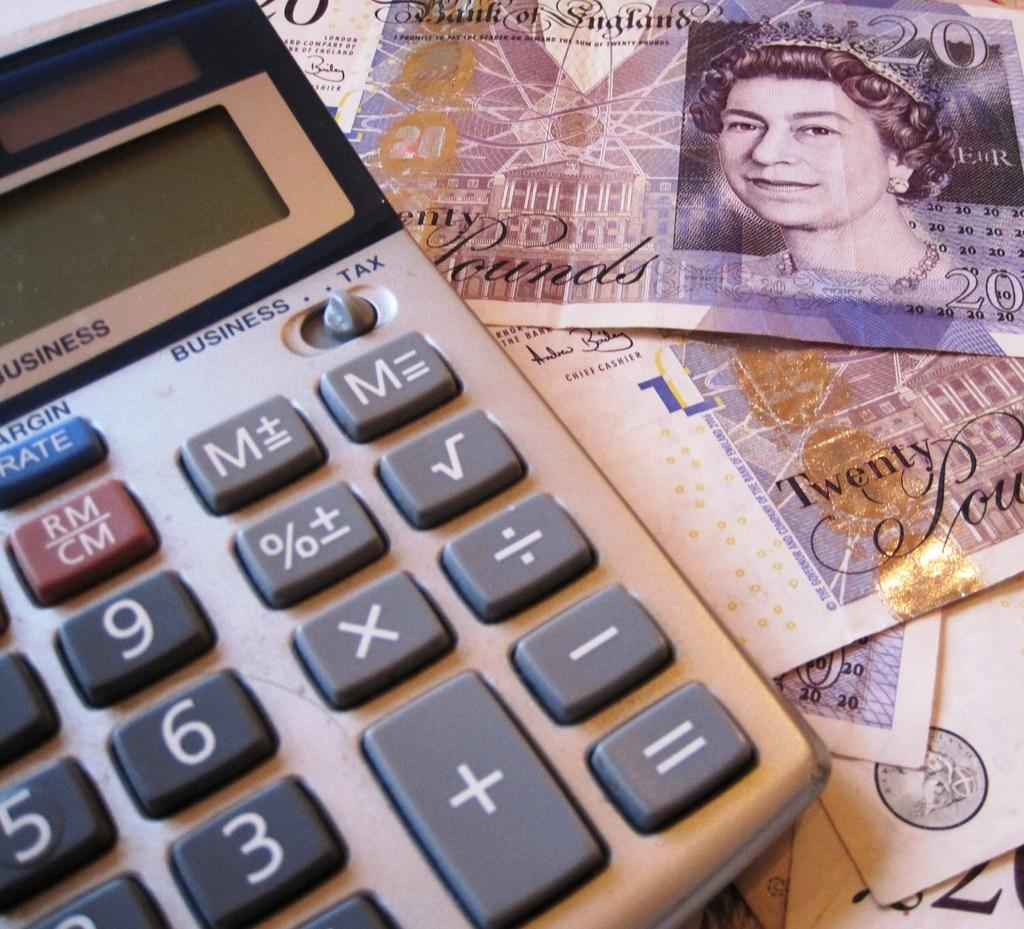<image>
Describe the image concisely. Twenty Pounds is written on the notes next to the calculator. 